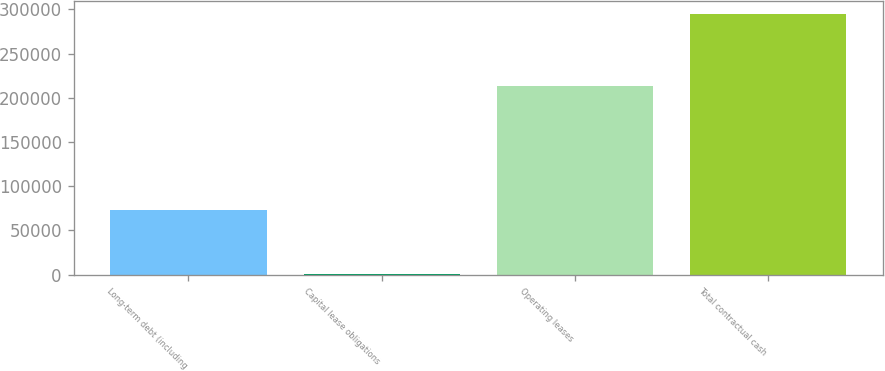Convert chart to OTSL. <chart><loc_0><loc_0><loc_500><loc_500><bar_chart><fcel>Long-term debt (including<fcel>Capital lease obligations<fcel>Operating leases<fcel>Total contractual cash<nl><fcel>72688<fcel>826<fcel>213523<fcel>294918<nl></chart> 